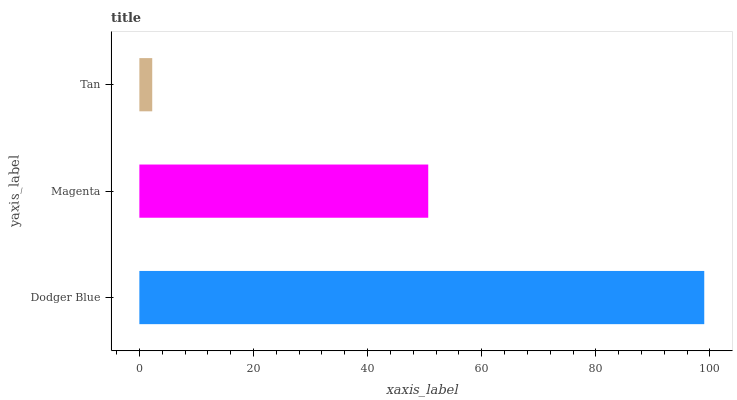Is Tan the minimum?
Answer yes or no. Yes. Is Dodger Blue the maximum?
Answer yes or no. Yes. Is Magenta the minimum?
Answer yes or no. No. Is Magenta the maximum?
Answer yes or no. No. Is Dodger Blue greater than Magenta?
Answer yes or no. Yes. Is Magenta less than Dodger Blue?
Answer yes or no. Yes. Is Magenta greater than Dodger Blue?
Answer yes or no. No. Is Dodger Blue less than Magenta?
Answer yes or no. No. Is Magenta the high median?
Answer yes or no. Yes. Is Magenta the low median?
Answer yes or no. Yes. Is Tan the high median?
Answer yes or no. No. Is Dodger Blue the low median?
Answer yes or no. No. 